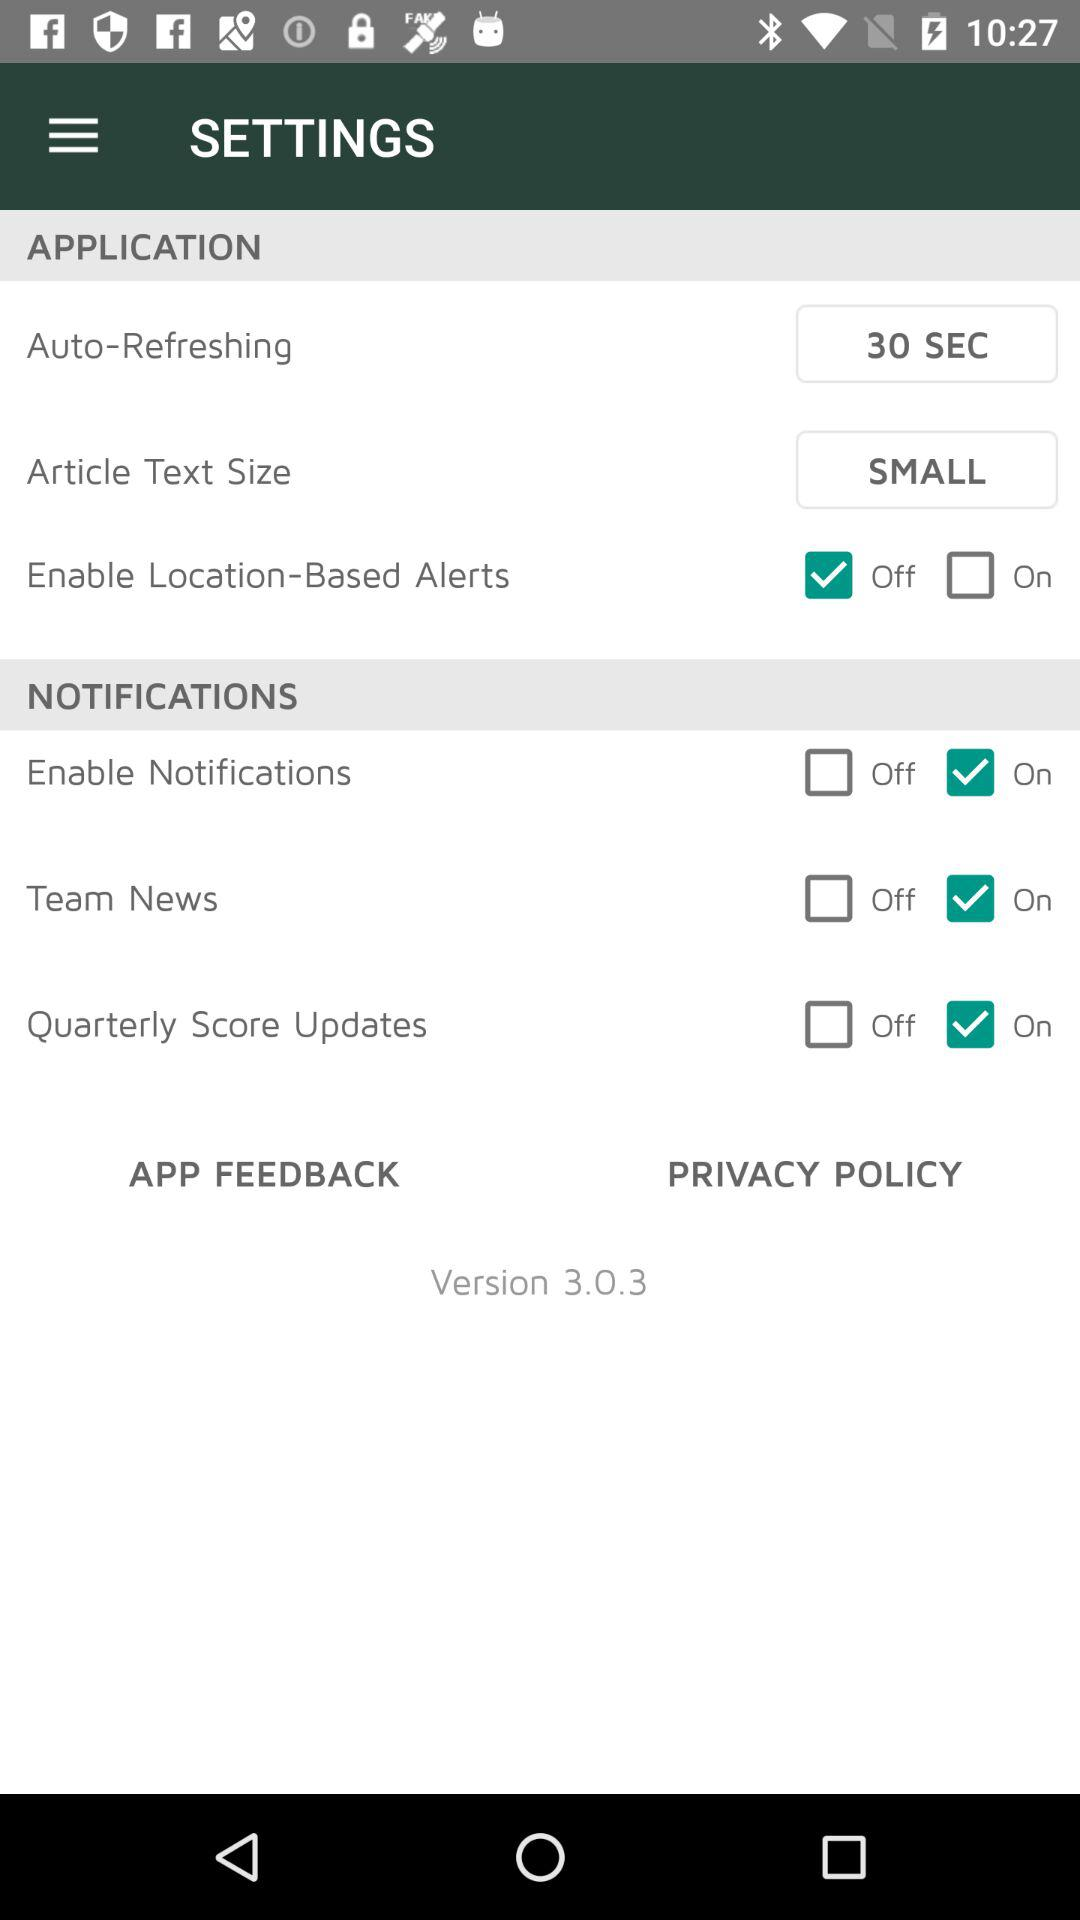What is the "Auto-Refreshing" duration? The "Auto-Refreshing" duration is 30 seconds. 